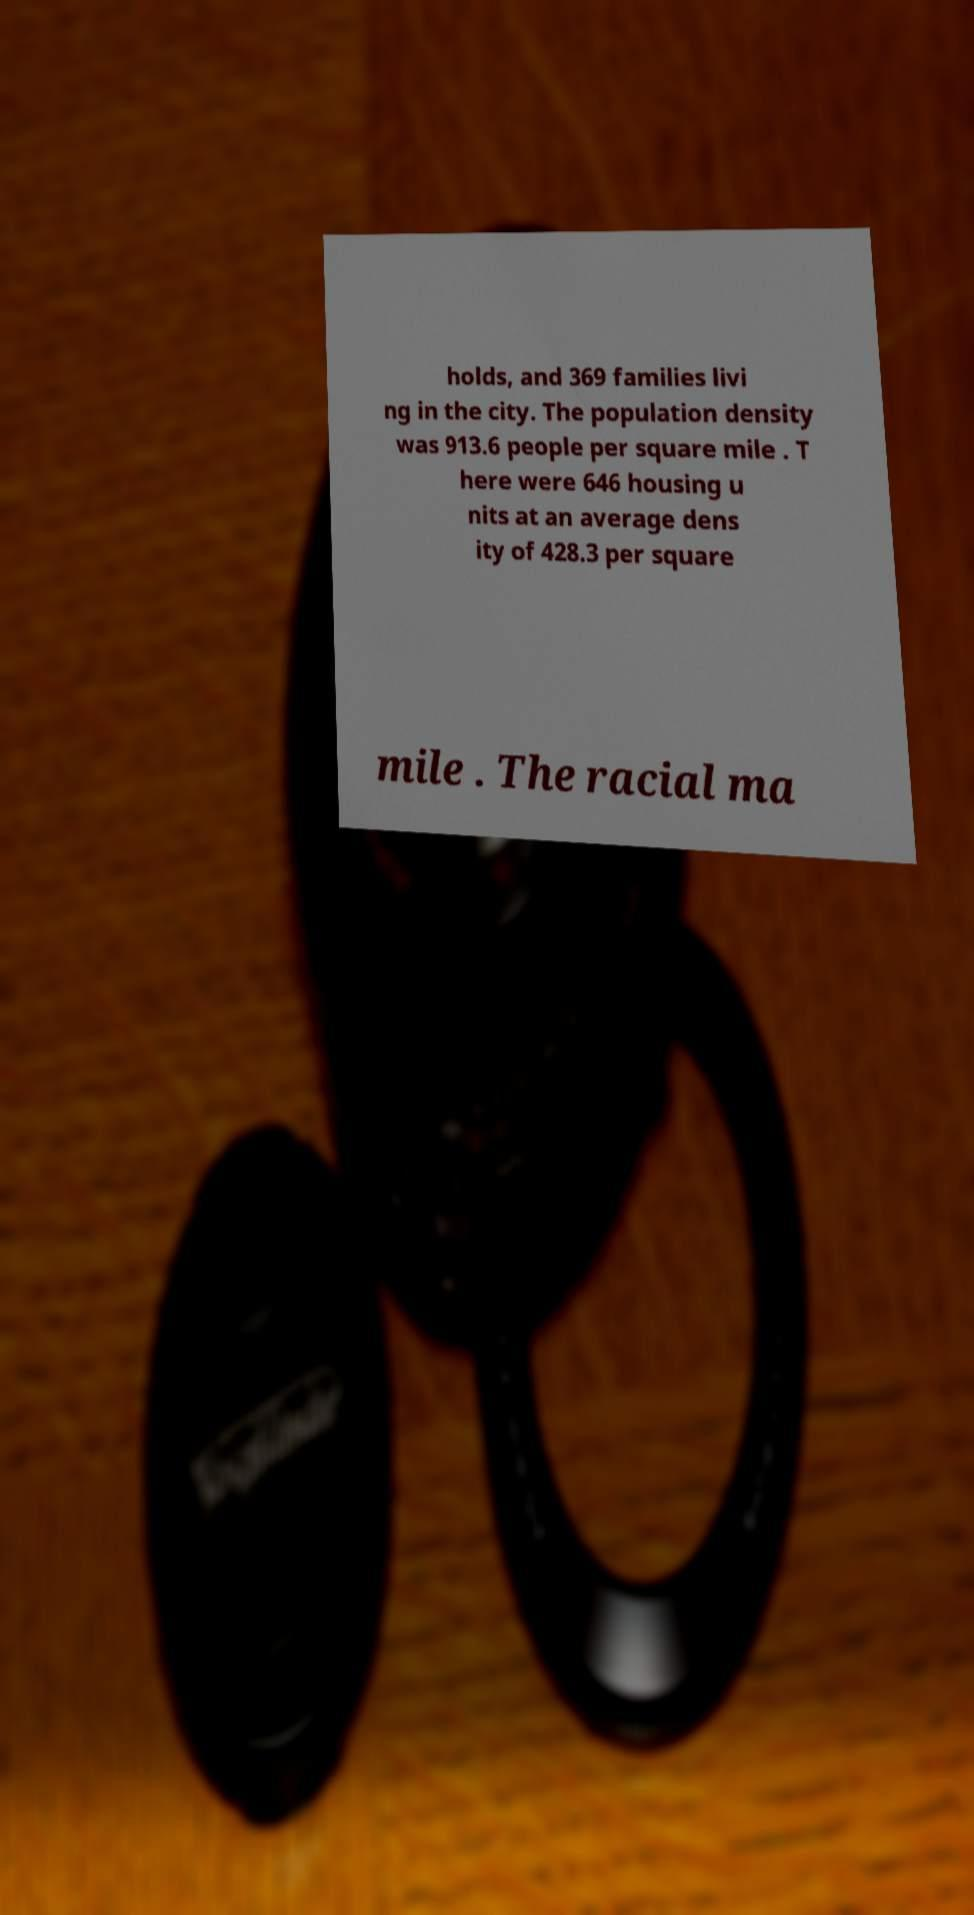What messages or text are displayed in this image? I need them in a readable, typed format. holds, and 369 families livi ng in the city. The population density was 913.6 people per square mile . T here were 646 housing u nits at an average dens ity of 428.3 per square mile . The racial ma 